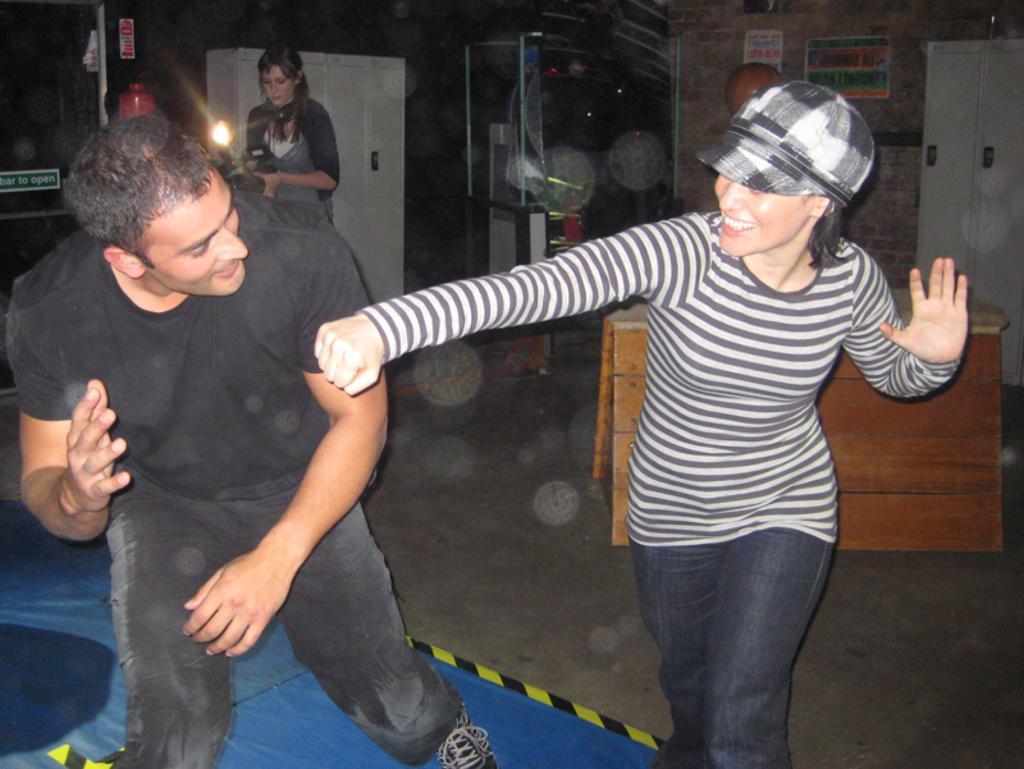How would you summarize this image in a sentence or two? In this picture there is a boy and a girl in the image and there are posters, cupboards and racks in the background area of the image. 